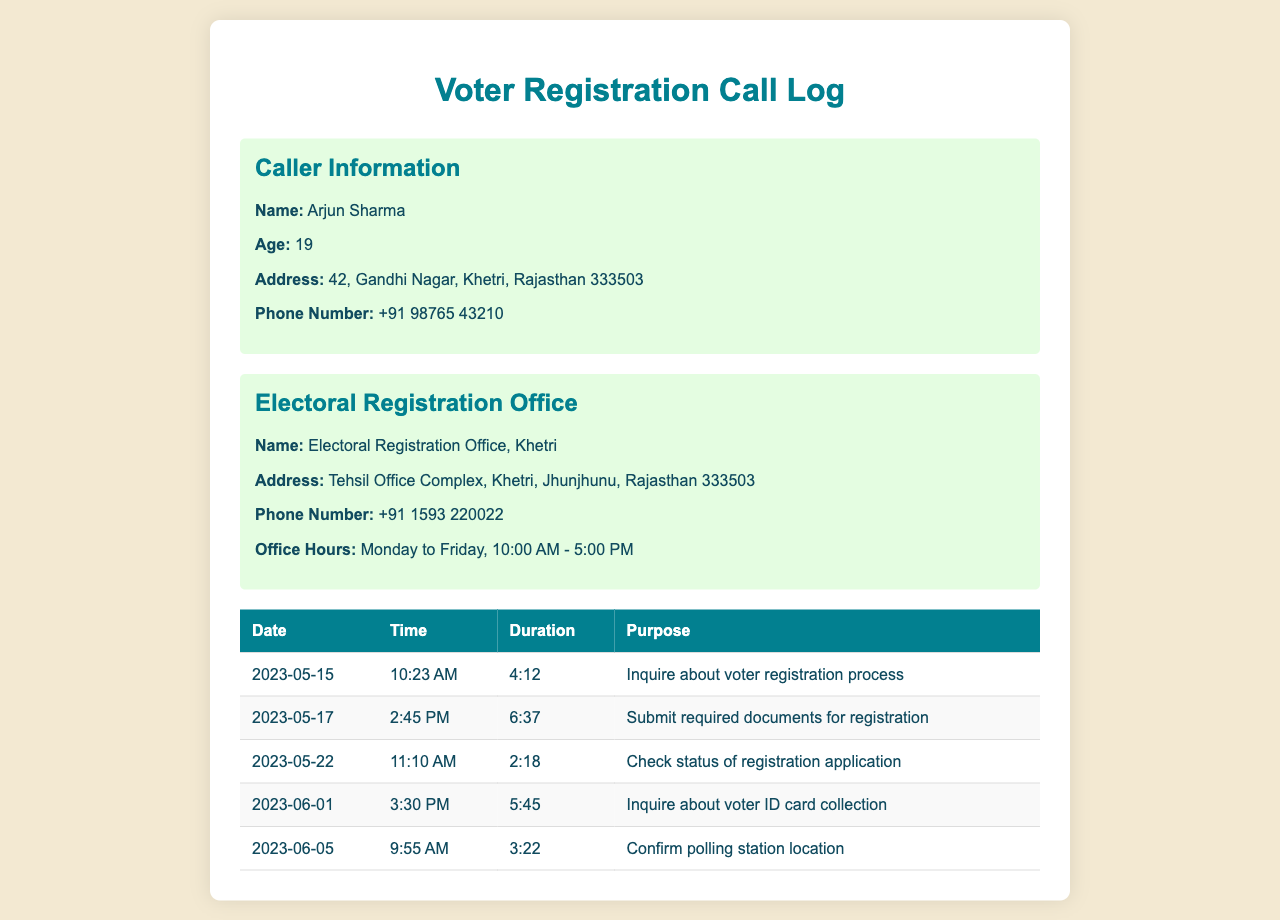What is the name of the caller? The name of the caller is listed at the beginning of the document, which is Arjun Sharma.
Answer: Arjun Sharma What is the phone number of the Electoral Registration Office? The phone number for the office is provided in the office information section, which is +91 1593 220022.
Answer: +91 1593 220022 What was the purpose of the call on 2023-05-17? The purpose of this call is specified in the call log on that date, which is to submit required documents for registration.
Answer: Submit required documents for registration How long did the call on 2023-06-01 last? The duration of the call is noted in the call log under that date, which is 5:45.
Answer: 5:45 What is the address of the caller? The address of the caller is listed in the caller information section, which is 42, Gandhi Nagar, Khetri, Rajasthan 333503.
Answer: 42, Gandhi Nagar, Khetri, Rajasthan 333503 What action did the caller take on 2023-05-22? The caller's action on this date is mentioned in the log, which is to check the status of the registration application.
Answer: Check status of registration application What days is the Electoral Registration Office open? The office hours are provided, indicating which days the office is open, which are Monday to Friday.
Answer: Monday to Friday What is the time of the earliest call made? The earliest call is recorded at 10:23 AM on 2023-05-15, specifying its start time.
Answer: 10:23 AM How many calls are listed in total? The total number of calls can be counted from the table in the document, which shows five entries.
Answer: 5 